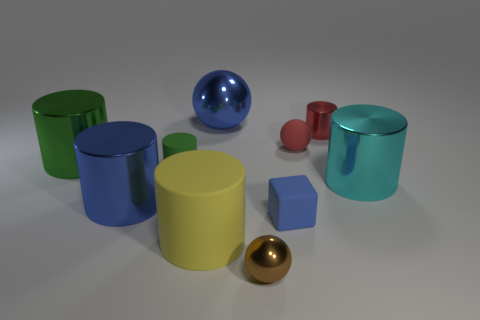Subtract all cyan balls. How many green cylinders are left? 2 Subtract 1 cylinders. How many cylinders are left? 5 Subtract all rubber cylinders. How many cylinders are left? 4 Subtract all cyan cylinders. How many cylinders are left? 5 Subtract all purple cylinders. Subtract all green balls. How many cylinders are left? 6 Subtract all balls. How many objects are left? 7 Add 3 large objects. How many large objects are left? 8 Add 3 purple matte cubes. How many purple matte cubes exist? 3 Subtract 0 gray cylinders. How many objects are left? 10 Subtract all tiny brown rubber cylinders. Subtract all big matte cylinders. How many objects are left? 9 